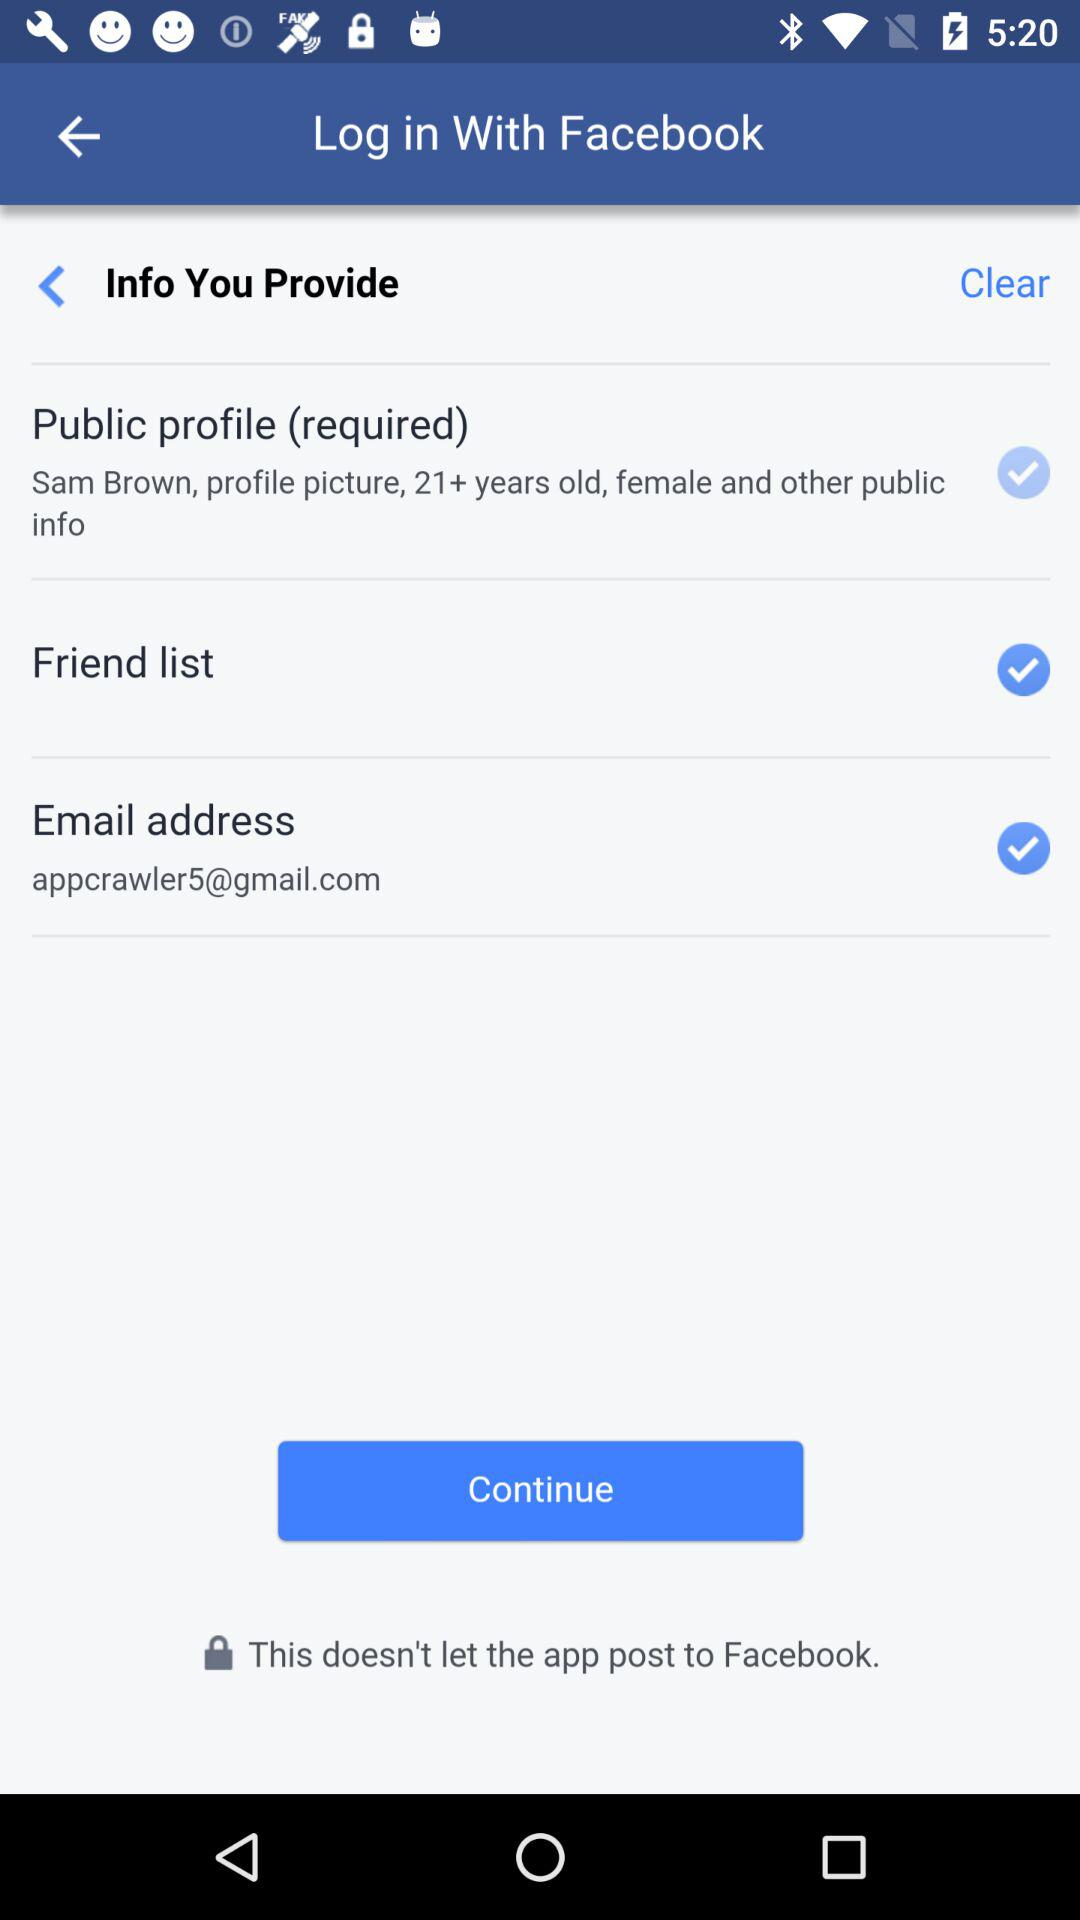What is the email address? The email address is appcrawler5@gmail.com. 